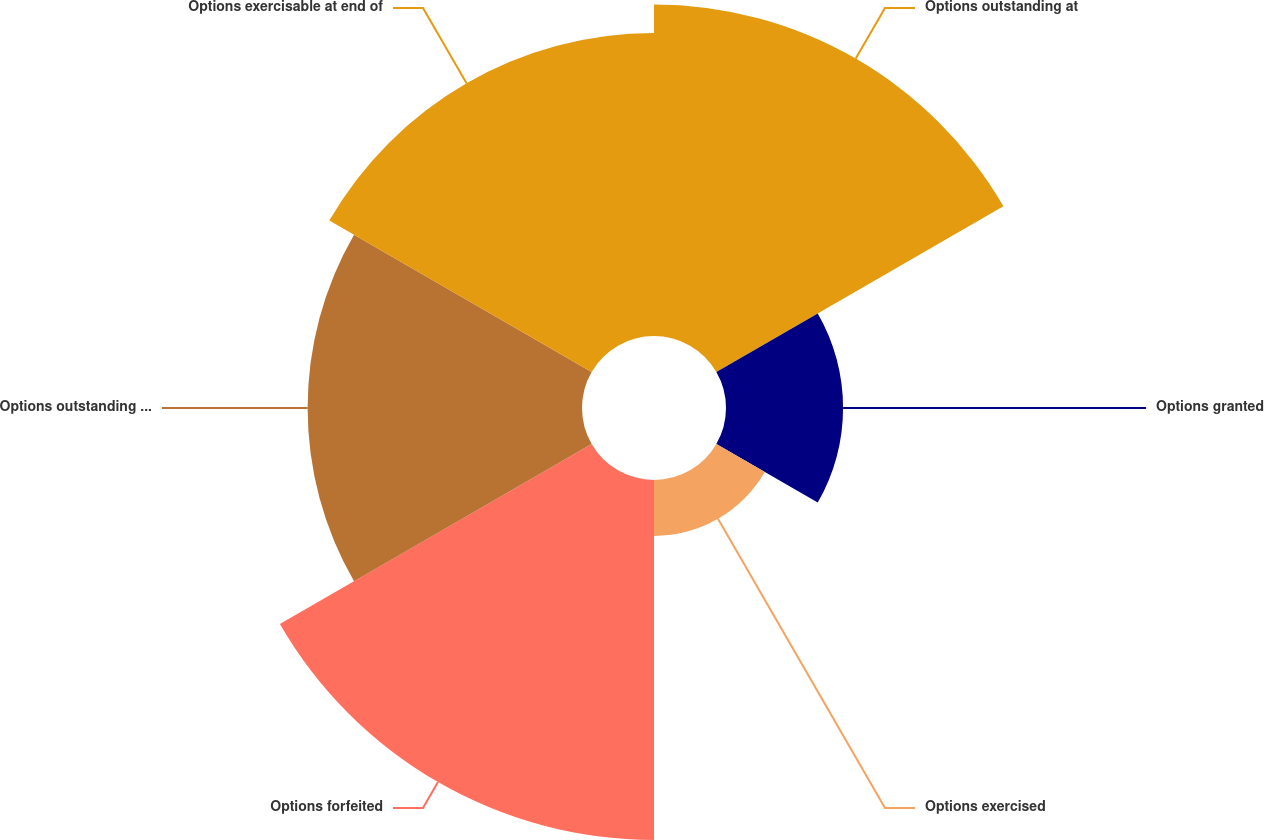Convert chart. <chart><loc_0><loc_0><loc_500><loc_500><pie_chart><fcel>Options outstanding at<fcel>Options granted<fcel>Options exercised<fcel>Options forfeited<fcel>Options outstanding at end of<fcel>Options exercisable at end of<nl><fcel>22.99%<fcel>8.12%<fcel>3.88%<fcel>24.97%<fcel>19.03%<fcel>21.01%<nl></chart> 